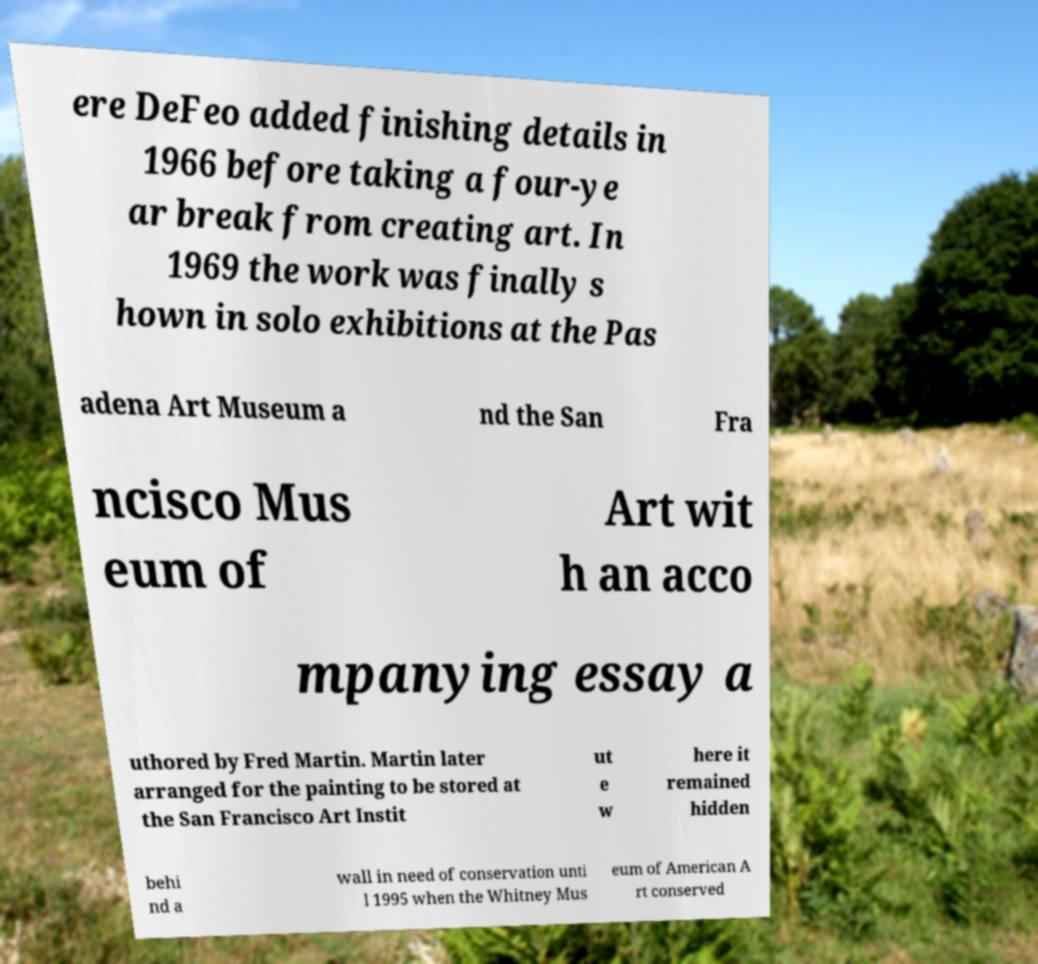Could you assist in decoding the text presented in this image and type it out clearly? ere DeFeo added finishing details in 1966 before taking a four-ye ar break from creating art. In 1969 the work was finally s hown in solo exhibitions at the Pas adena Art Museum a nd the San Fra ncisco Mus eum of Art wit h an acco mpanying essay a uthored by Fred Martin. Martin later arranged for the painting to be stored at the San Francisco Art Instit ut e w here it remained hidden behi nd a wall in need of conservation unti l 1995 when the Whitney Mus eum of American A rt conserved 